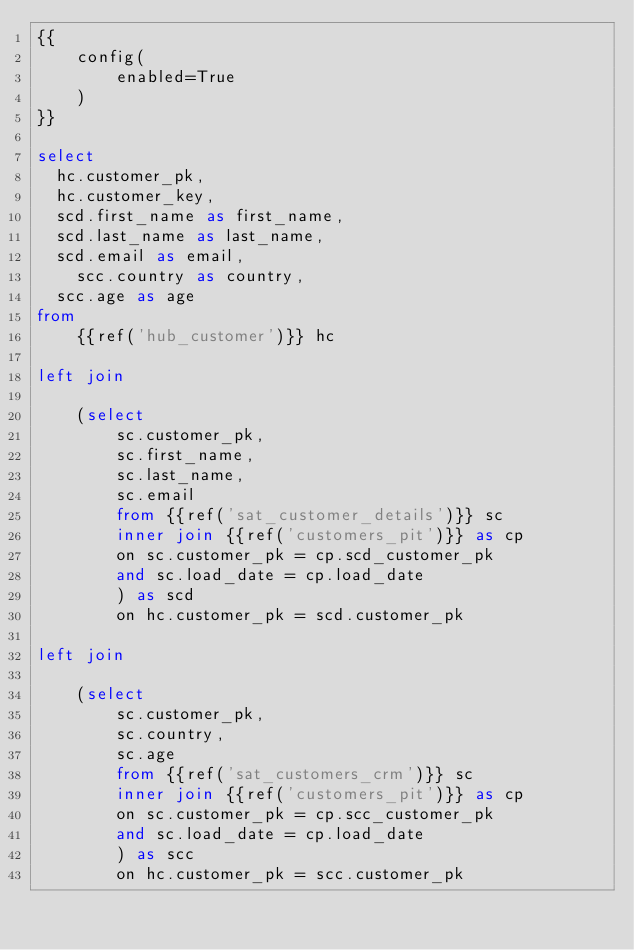<code> <loc_0><loc_0><loc_500><loc_500><_SQL_>{{
    config(
        enabled=True
    )
}}

select 
	hc.customer_pk, 
	hc.customer_key, 	
	scd.first_name as first_name,
	scd.last_name as last_name,
	scd.email as email,
    scc.country as country,
	scc.age as age
from 
    {{ref('hub_customer')}} hc    

left join 

    (select 
        sc.customer_pk,
        sc.first_name,
        sc.last_name,
        sc.email
        from {{ref('sat_customer_details')}} sc
        inner join {{ref('customers_pit')}} as cp
        on sc.customer_pk = cp.scd_customer_pk
        and sc.load_date = cp.load_date
        ) as scd
        on hc.customer_pk = scd.customer_pk

left join 

    (select     
        sc.customer_pk,
        sc.country,
        sc.age
        from {{ref('sat_customers_crm')}} sc
        inner join {{ref('customers_pit')}} as cp
        on sc.customer_pk = cp.scc_customer_pk
        and sc.load_date = cp.load_date
        ) as scc
        on hc.customer_pk = scc.customer_pk
</code> 